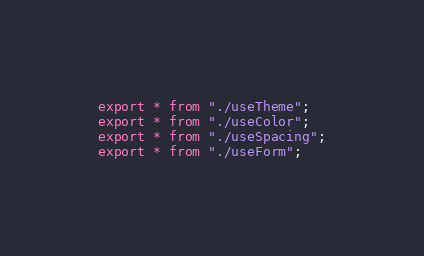Convert code to text. <code><loc_0><loc_0><loc_500><loc_500><_TypeScript_>export * from "./useTheme";
export * from "./useColor";
export * from "./useSpacing";
export * from "./useForm";
</code> 